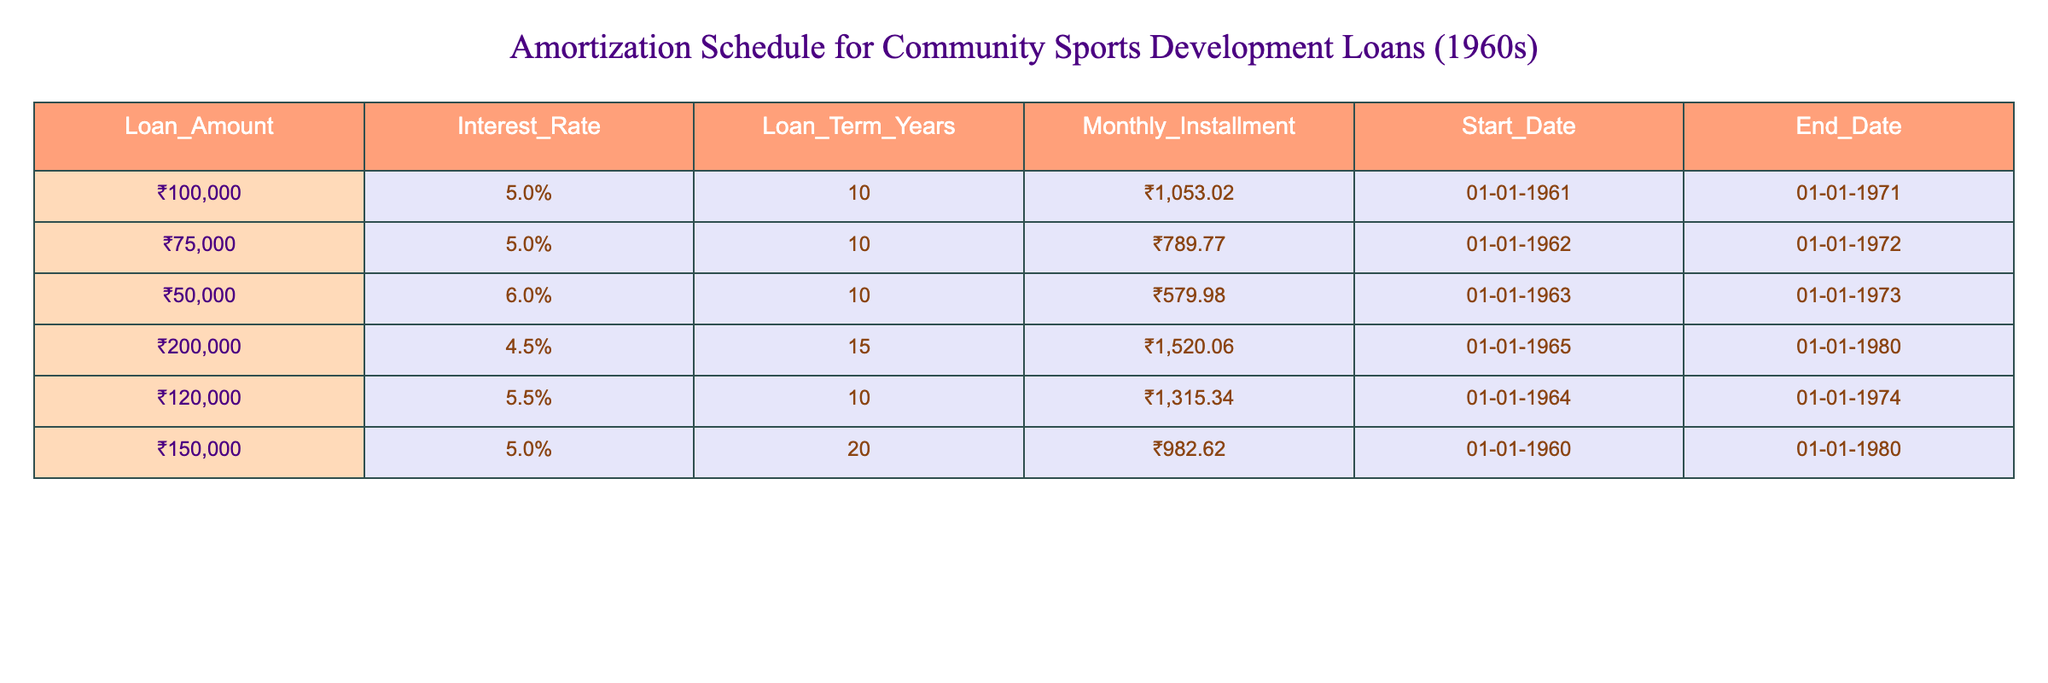What is the loan amount for the community sports development project initiated in 1965? Referring to the table, the entry for the project in 1965 shows a loan amount of ₹200,000.
Answer: ₹200,000 How many years is the loan term for the ₹50,000 loan that started in 1963? The loan amount of ₹50,000 has a term of 10 years as indicated in the table.
Answer: 10 years What is the monthly installment for the loan that started in 1960? The loan that began in 1960 has a monthly installment of ₹982.62 as stated in the table.
Answer: ₹982.62 Which loan has the highest interest rate, and what is that rate? By examining all the interest rates in the table, the highest is 6%, which belongs to the loan that started in 1963.
Answer: 6% What is the total amount of monthly installments for the loans starting in 1961 and 1962 combined? First, identify the monthly installments: for the loan starting in 1961 it's ₹1,053.02, and for the loan starting in 1962 it's ₹789.77. Adding these gives ₹1,053.02 + ₹789.77 = ₹1,842.79.
Answer: ₹1,842.79 Is the loan term for the ₹120,000 loan longer than that of the ₹200,000 loan? The ₹120,000 loan has a term of 10 years, and the ₹200,000 loan has a term of 15 years. Since 15 years is longer than 10 years, the answer is yes.
Answer: Yes What is the average loan amount for all loans listed in the table? To find the average, sum all the loan amounts: ₹100,000 + ₹75,000 + ₹50,000 + ₹200,000 + ₹120,000 + ₹150,000 = ₹695,000. There are 6 loans, so average = ₹695,000 / 6 = ₹115,833.33.
Answer: ₹115,833.33 Which loan had the lowest monthly installment, and what was that amount? The loan amount of ₹50,000 from 1963 has the lowest installment at ₹579.98, based on the amounts detailed in the table.
Answer: ₹579.98 What is the difference between the loan amounts of the loans starting in 1961 and 1965? The loan starting in 1961 is ₹100,000 and the one in 1965 is ₹200,000. The difference is ₹200,000 - ₹100,000 = ₹100,000.
Answer: ₹100,000 